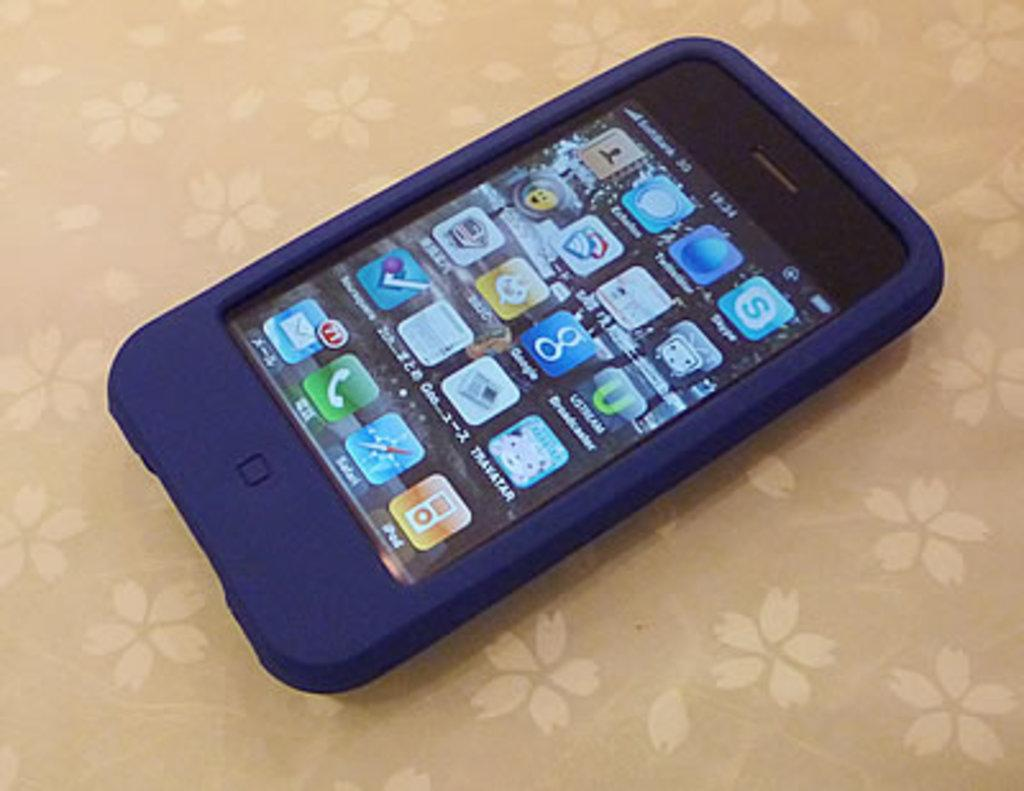<image>
Present a compact description of the photo's key features. A cell phone with a dark blue case displays that there are 71 unread emails. 